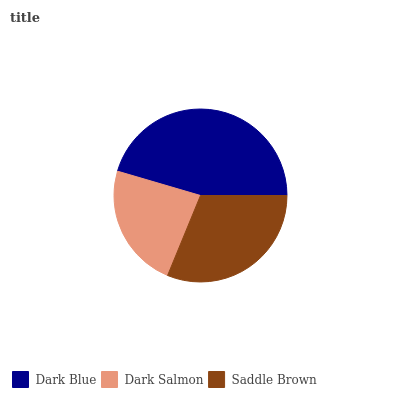Is Dark Salmon the minimum?
Answer yes or no. Yes. Is Dark Blue the maximum?
Answer yes or no. Yes. Is Saddle Brown the minimum?
Answer yes or no. No. Is Saddle Brown the maximum?
Answer yes or no. No. Is Saddle Brown greater than Dark Salmon?
Answer yes or no. Yes. Is Dark Salmon less than Saddle Brown?
Answer yes or no. Yes. Is Dark Salmon greater than Saddle Brown?
Answer yes or no. No. Is Saddle Brown less than Dark Salmon?
Answer yes or no. No. Is Saddle Brown the high median?
Answer yes or no. Yes. Is Saddle Brown the low median?
Answer yes or no. Yes. Is Dark Salmon the high median?
Answer yes or no. No. Is Dark Salmon the low median?
Answer yes or no. No. 